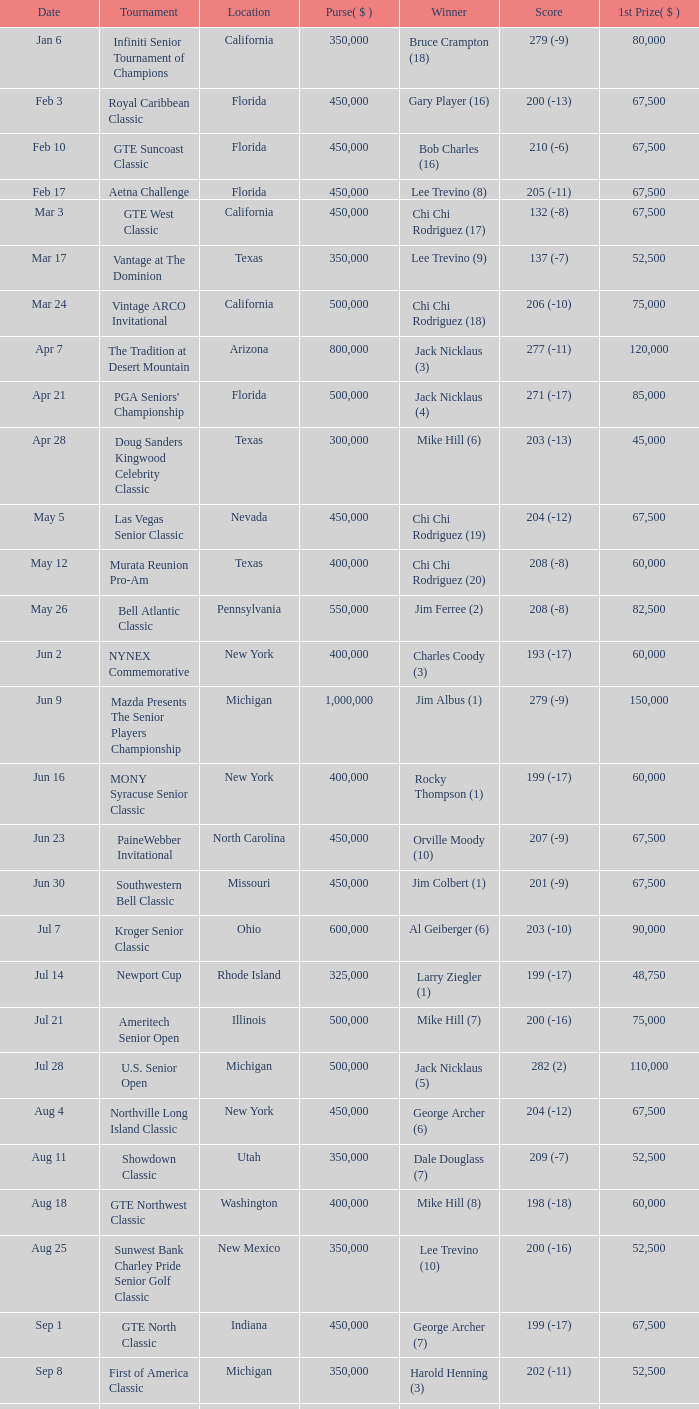Where was the security pacific senior classic? California. 